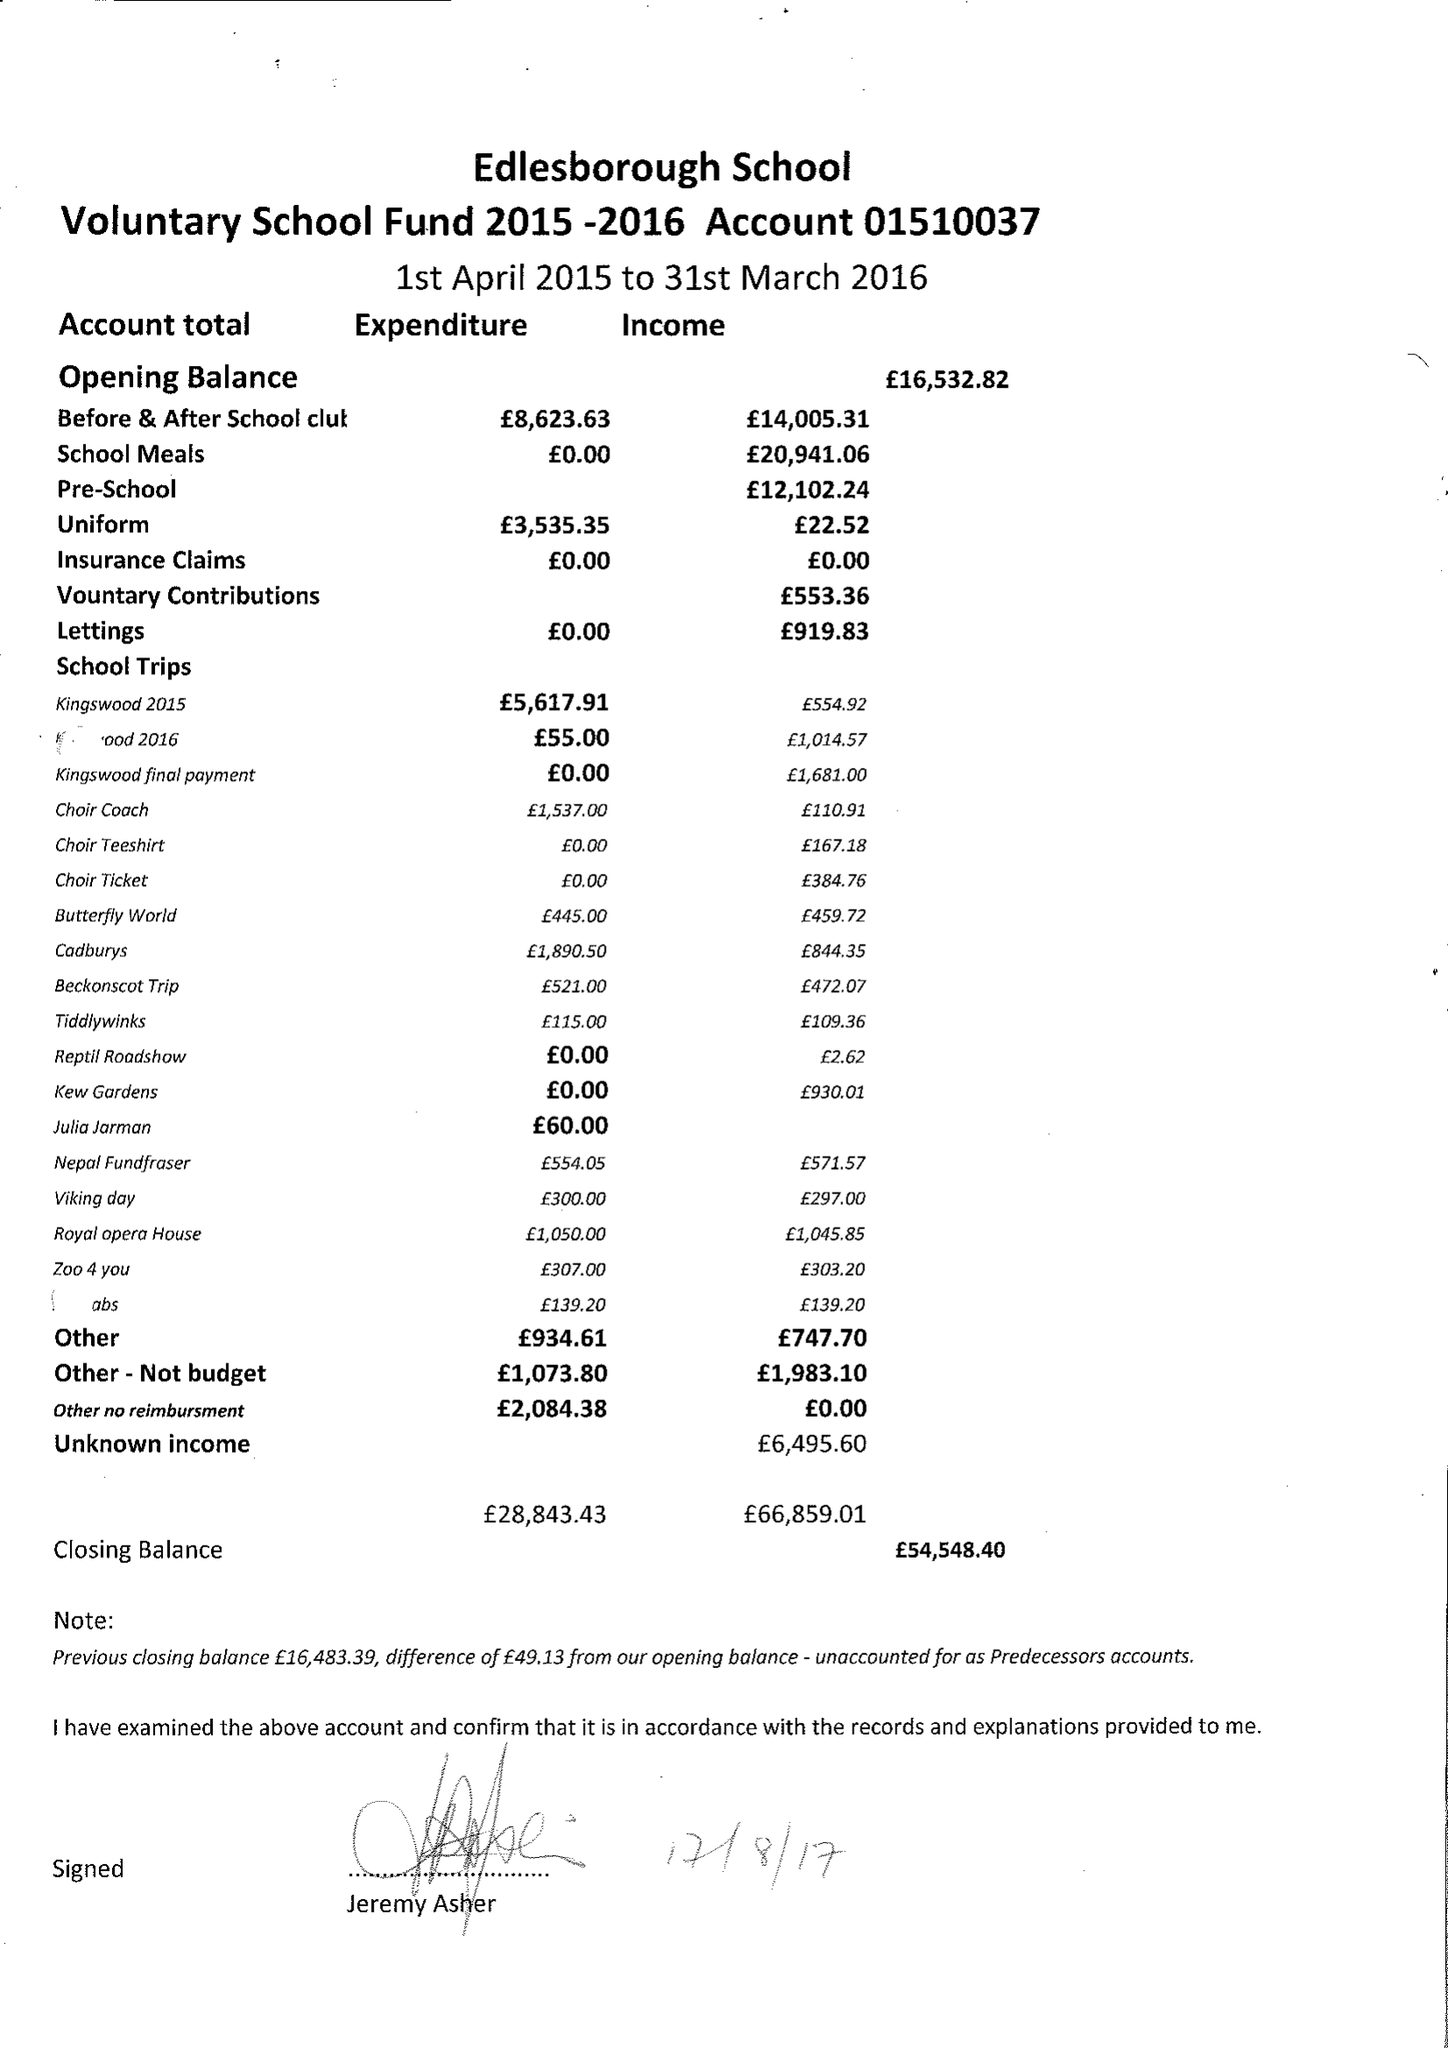What is the value for the charity_number?
Answer the question using a single word or phrase. 1067917 